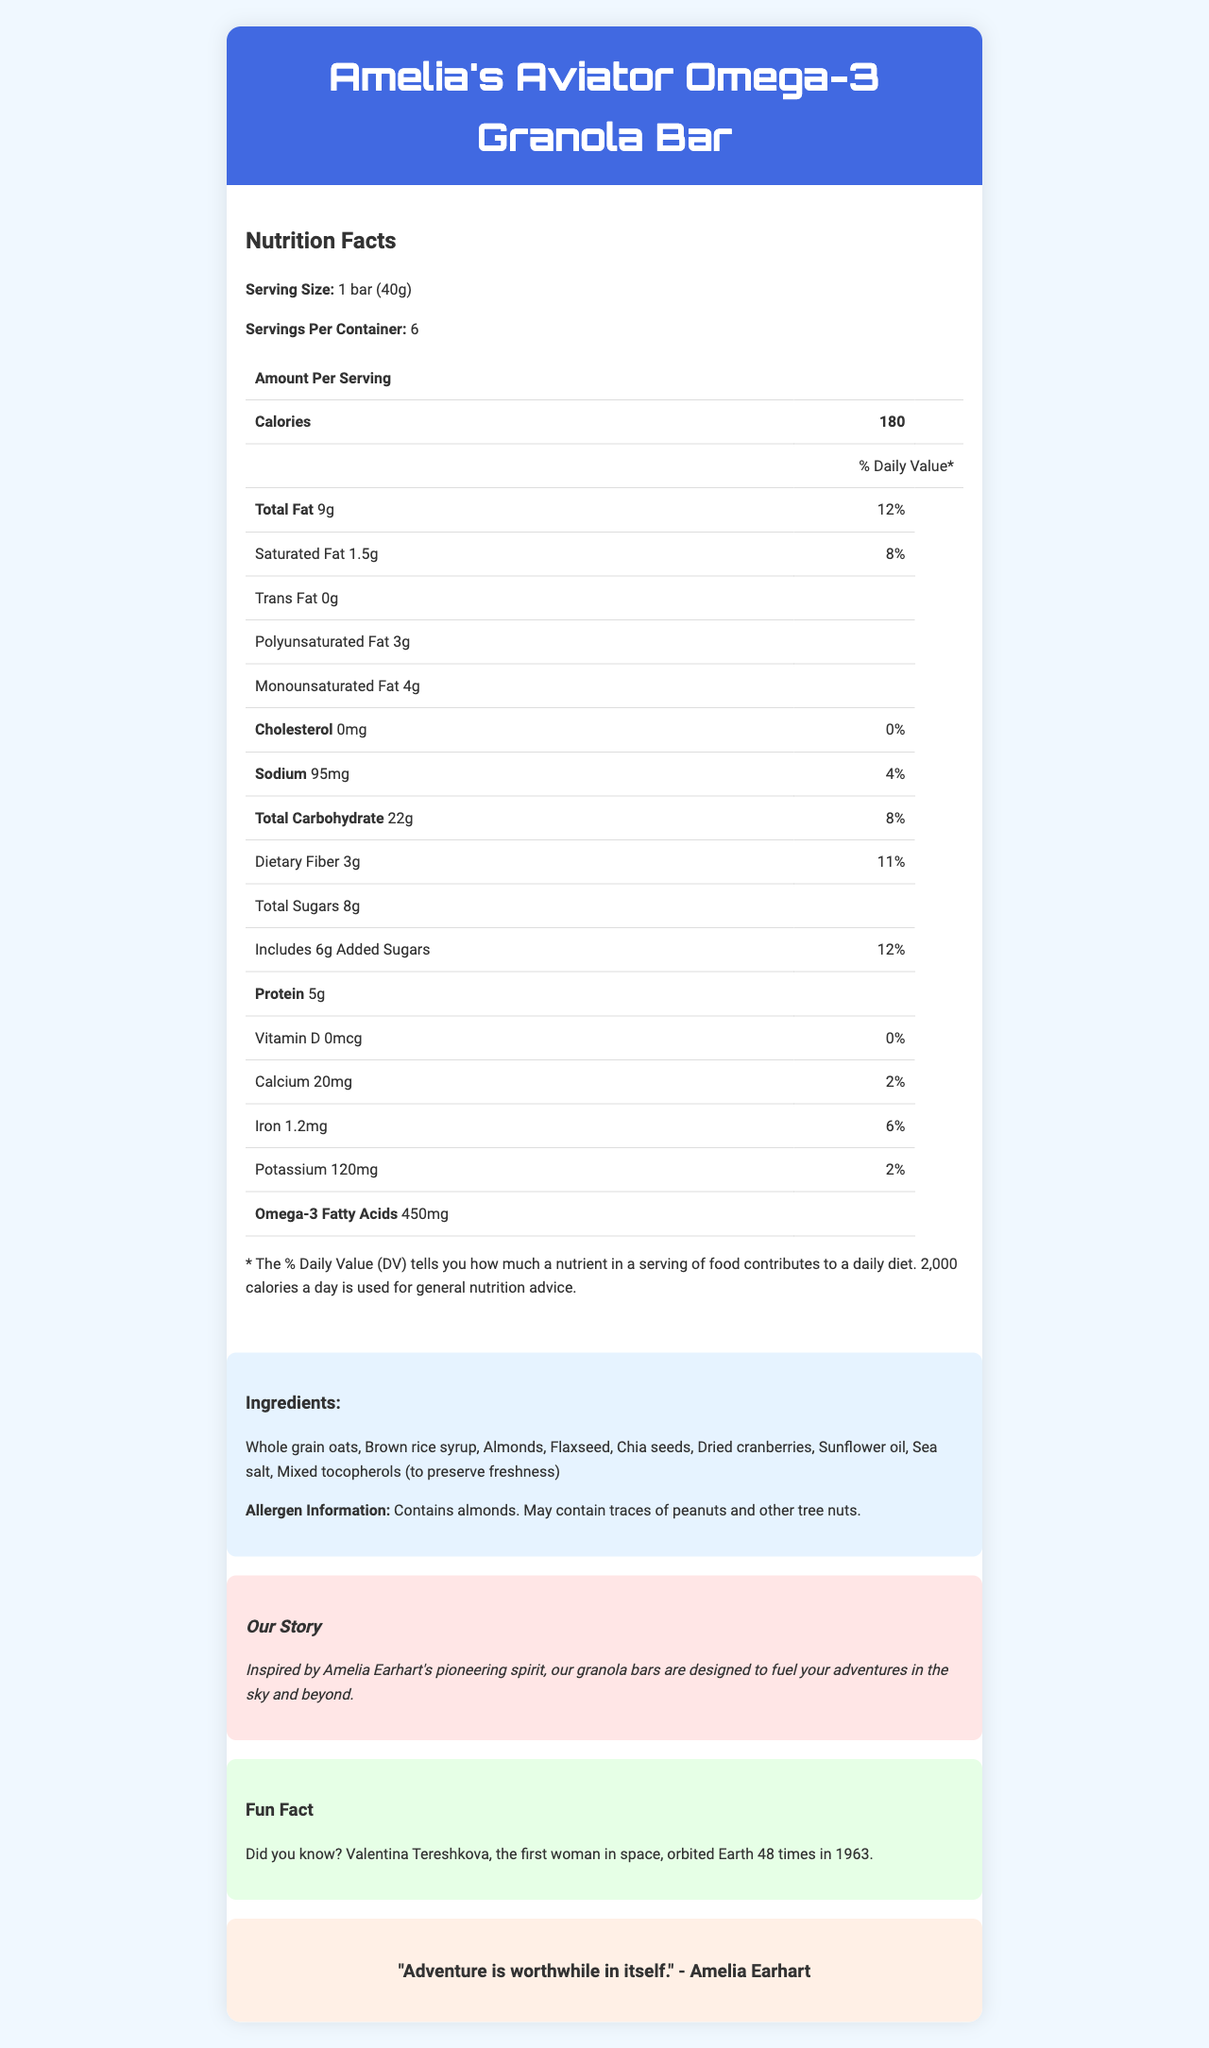What is the serving size of Amelia's Aviator Omega-3 Granola Bar? The serving size is listed as "1 bar (40g)" on the document.
Answer: 1 bar (40g) How many servings are in a container of these granola bars? The document states there are 6 servings per container.
Answer: 6 What is the total amount of omega-3 fatty acids in one serving of the granola bar? The nutrition facts list the amount of omega-3 fatty acids as 450mg per serving.
Answer: 450mg Does the product contain any trans fat? The document specifies "Trans Fat 0g" under the nutrition facts.
Answer: No How much dietary fiber is in one bar? The dietary fiber content is detailed as "3g" in the nutrition facts.
Answer: 3g What pioneering woman inspired the brand of this granola bar? The brand story mentions, "Inspired by Amelia Earhart's pioneering spirit."
Answer: Amelia Earhart How many calories are in a single granola bar? The document shows that each serving has 180 calories.
Answer: 180 Which of the following ingredients is used in the granola bar?
A. Peanuts
B. Almonds
C. Cashews The ingredients list includes almonds but makes no mention of peanuts or cashews.
Answer: B Does this product contain any added sugars? Under the total sugars section, it states that there are 6g of added sugars.
Answer: Yes How much total fat is in one serving, and what is its daily value percentage? The total fat content is 9g, which is 12% of the daily value.
Answer: 9g, 12% Who was the first woman in space, according to the fun fact on the document? The fun fact states that Valentina Tereshkova was the first woman in space and orbited Earth 48 times in 1963.
Answer: Valentina Tereshkova Which nutrient is not present in this granola bar? 
A. Vitamin D 
B. Iron 
C. Sodium The document states that vitamin D is 0mcg with 0% daily value, whereas iron and sodium have non-zero values.
Answer: A Is there any cholesterol in the granola bar? The document shows "Cholesterol 0mg" with a daily value of "0%."
Answer: No Summarize the main information provided in the document. The document is primarily about the nutritional details of the granola bar named after Amelia Earhart, emphasizing its health benefits and inspirations from pioneering women in aerospace.
Answer: The document provides detailed nutrition facts for "Amelia's Aviator Omega-3 Granola Bar," listing various nutrients and their daily values. The bar has no trans fat, cholesterol, or vitamin D but includes omega-3 fatty acids. Aside from nutritional information, the document shares a brand story inspired by Amelia Earhart, highlights of allergen information, and a fun fact about Valentina Tereshkova, the first woman in space. How many grams of total carbohydrates are in one serving of the granola bar? The total carbohydrate content per serving is listed as 22g.
Answer: 22g Which type of fat has the highest amount in one serving of the granola bar?
A. Saturated fat
B. Polyunsaturated fat
C. Monounsaturated fat The monounsaturated fat is 4g, which is higher than the saturated fat (1.5g) and polyunsaturated fat (3g).
Answer: C Does this granola bar include any ingredients to preserve freshness? The ingredient list includes "Mixed tocopherols (to preserve freshness)."
Answer: Yes What is Amelia Earhart's quote mentioned in the document? The quote by Amelia Earhart is highlighted in a designated section of the document.
Answer: "Adventure is worthwhile in itself." How much sodium is in the granola bar? The sodium content is listed as 95mg per serving.
Answer: 95mg Are vitamin D levels in this granola bar sufficiently high to contribute to daily dietary needs? The document lists vitamin D as 0mcg with a daily value of 0%.
Answer: No Can you determine the exact manufacturing process of the granola bar from the document? The document does not provide specific details about the manufacturing process.
Answer: Not enough information 